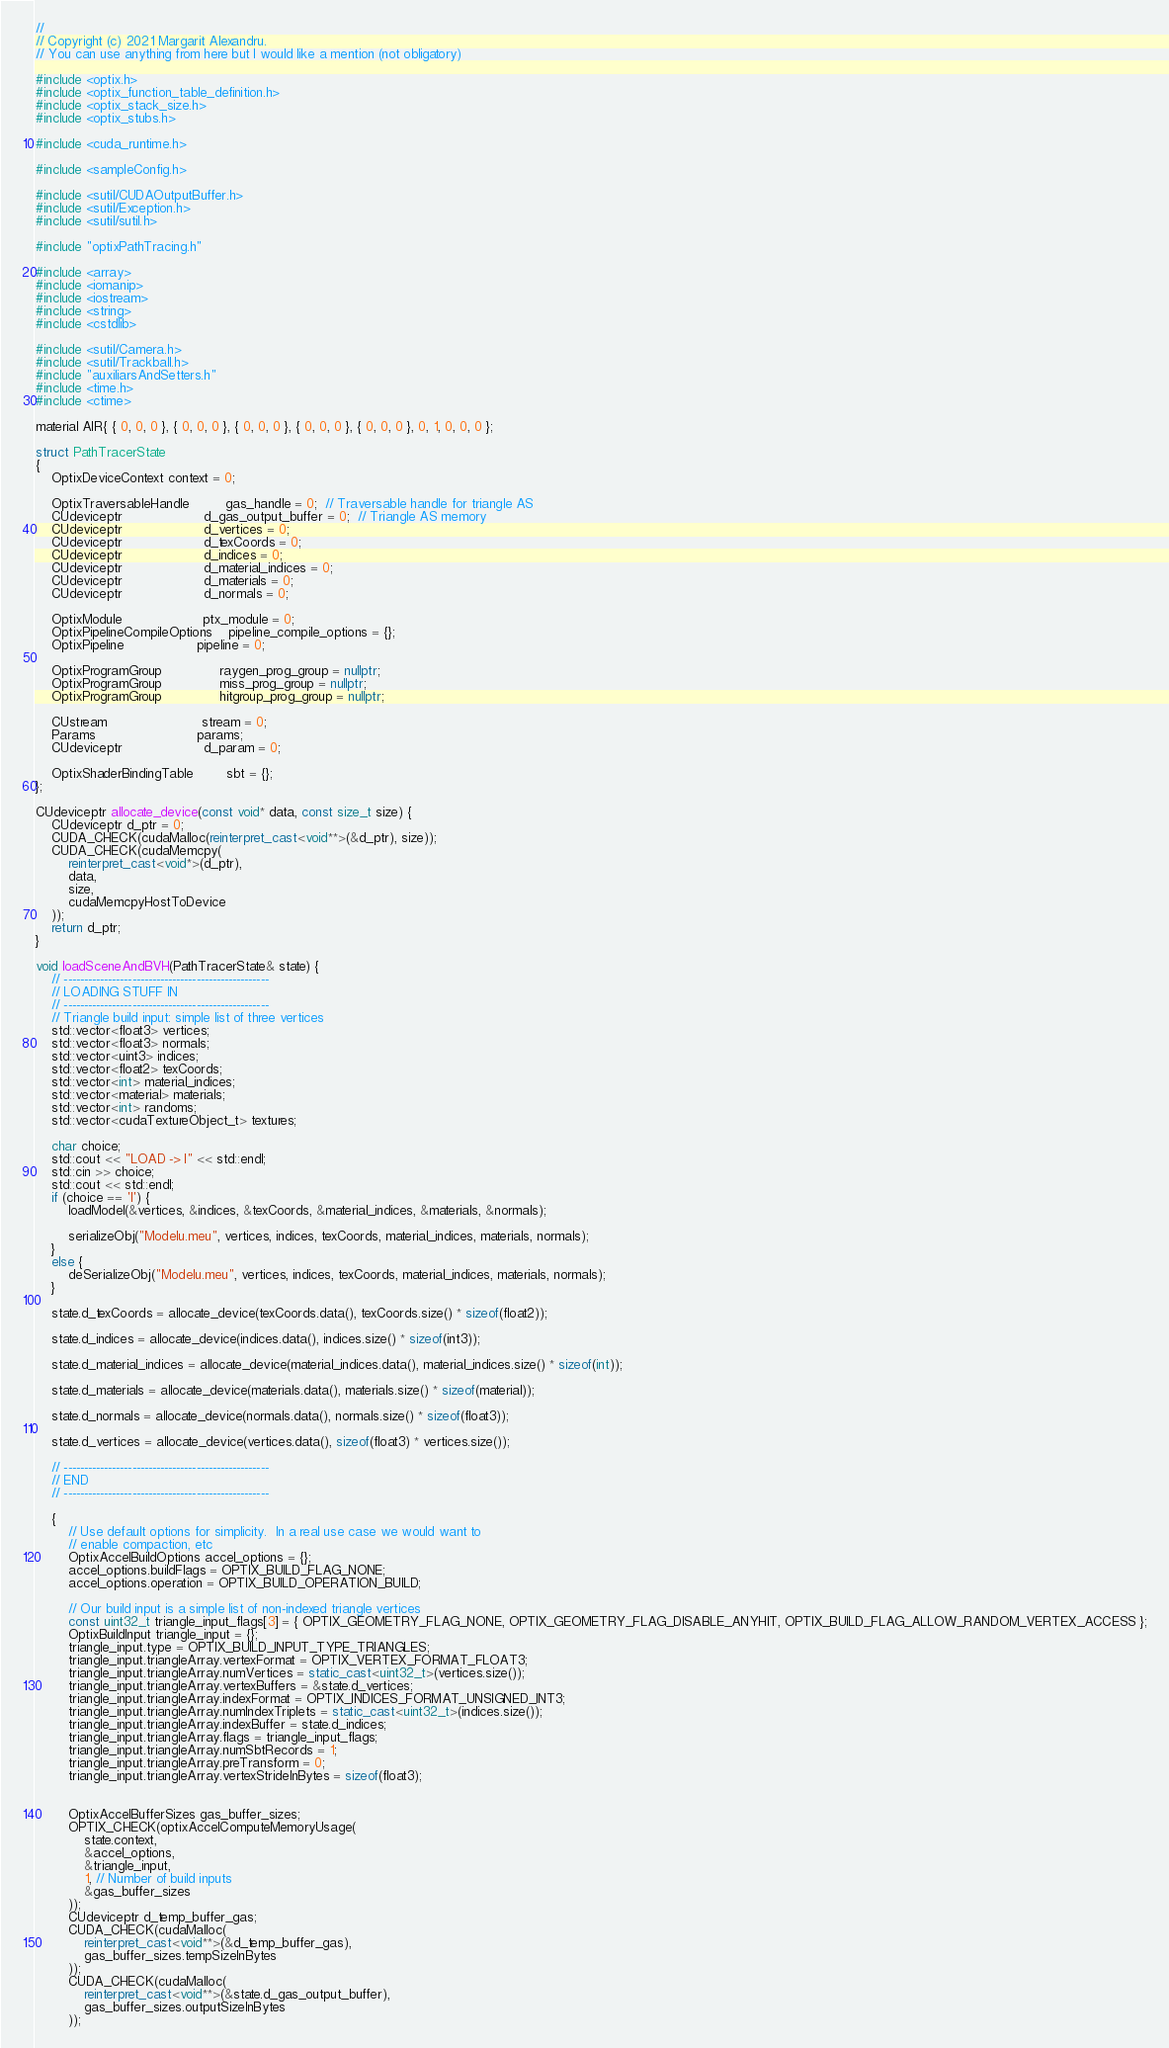<code> <loc_0><loc_0><loc_500><loc_500><_C++_>//
// Copyright (c) 2021 Margarit Alexandru.
// You can use anything from here but I would like a mention (not obligatory)

#include <optix.h>
#include <optix_function_table_definition.h>
#include <optix_stack_size.h>
#include <optix_stubs.h>

#include <cuda_runtime.h>

#include <sampleConfig.h>

#include <sutil/CUDAOutputBuffer.h>
#include <sutil/Exception.h>
#include <sutil/sutil.h>

#include "optixPathTracing.h"

#include <array>
#include <iomanip>
#include <iostream>
#include <string>
#include <cstdlib>

#include <sutil/Camera.h>
#include <sutil/Trackball.h>
#include "auxiliarsAndSetters.h"
#include <time.h>
#include <ctime>

material AIR{ { 0, 0, 0 }, { 0, 0, 0 }, { 0, 0, 0 }, { 0, 0, 0 }, { 0, 0, 0 }, 0, 1, 0, 0, 0 };

struct PathTracerState
{
    OptixDeviceContext context = 0;

    OptixTraversableHandle         gas_handle = 0;  // Traversable handle for triangle AS
    CUdeviceptr                    d_gas_output_buffer = 0;  // Triangle AS memory
    CUdeviceptr                    d_vertices = 0;
    CUdeviceptr                    d_texCoords = 0;
    CUdeviceptr                    d_indices = 0;
    CUdeviceptr                    d_material_indices = 0;
    CUdeviceptr                    d_materials = 0;
    CUdeviceptr                    d_normals = 0;

    OptixModule                    ptx_module = 0;
    OptixPipelineCompileOptions    pipeline_compile_options = {};
    OptixPipeline                  pipeline = 0;

    OptixProgramGroup              raygen_prog_group = nullptr;
    OptixProgramGroup              miss_prog_group = nullptr;
    OptixProgramGroup              hitgroup_prog_group = nullptr;

    CUstream                       stream = 0;
    Params                         params;
    CUdeviceptr                    d_param = 0;

    OptixShaderBindingTable        sbt = {};
};

CUdeviceptr allocate_device(const void* data, const size_t size) {
    CUdeviceptr d_ptr = 0;
    CUDA_CHECK(cudaMalloc(reinterpret_cast<void**>(&d_ptr), size));
    CUDA_CHECK(cudaMemcpy(
        reinterpret_cast<void*>(d_ptr),
        data,
        size,
        cudaMemcpyHostToDevice
    ));
    return d_ptr;
}

void loadSceneAndBVH(PathTracerState& state) {
    // ---------------------------------------------------
    // LOADING STUFF IN
    // ---------------------------------------------------
    // Triangle build input: simple list of three vertices
    std::vector<float3> vertices;
    std::vector<float3> normals;
    std::vector<uint3> indices;
    std::vector<float2> texCoords;
    std::vector<int> material_indices;
    std::vector<material> materials;
    std::vector<int> randoms;
    std::vector<cudaTextureObject_t> textures;

    char choice;
    std::cout << "LOAD -> l" << std::endl;
    std::cin >> choice;
    std::cout << std::endl;
    if (choice == 'l') {
        loadModel(&vertices, &indices, &texCoords, &material_indices, &materials, &normals);

        serializeObj("Modelu.meu", vertices, indices, texCoords, material_indices, materials, normals);
    }
    else {
        deSerializeObj("Modelu.meu", vertices, indices, texCoords, material_indices, materials, normals);
    }

    state.d_texCoords = allocate_device(texCoords.data(), texCoords.size() * sizeof(float2));

    state.d_indices = allocate_device(indices.data(), indices.size() * sizeof(int3));

    state.d_material_indices = allocate_device(material_indices.data(), material_indices.size() * sizeof(int));

    state.d_materials = allocate_device(materials.data(), materials.size() * sizeof(material));

    state.d_normals = allocate_device(normals.data(), normals.size() * sizeof(float3));

    state.d_vertices = allocate_device(vertices.data(), sizeof(float3) * vertices.size());

    // ---------------------------------------------------
    // END
    // ---------------------------------------------------

    {
        // Use default options for simplicity.  In a real use case we would want to
        // enable compaction, etc
        OptixAccelBuildOptions accel_options = {};
        accel_options.buildFlags = OPTIX_BUILD_FLAG_NONE;
        accel_options.operation = OPTIX_BUILD_OPERATION_BUILD;

        // Our build input is a simple list of non-indexed triangle vertices
        const uint32_t triangle_input_flags[3] = { OPTIX_GEOMETRY_FLAG_NONE, OPTIX_GEOMETRY_FLAG_DISABLE_ANYHIT, OPTIX_BUILD_FLAG_ALLOW_RANDOM_VERTEX_ACCESS };
        OptixBuildInput triangle_input = {};
        triangle_input.type = OPTIX_BUILD_INPUT_TYPE_TRIANGLES;
        triangle_input.triangleArray.vertexFormat = OPTIX_VERTEX_FORMAT_FLOAT3;
        triangle_input.triangleArray.numVertices = static_cast<uint32_t>(vertices.size());
        triangle_input.triangleArray.vertexBuffers = &state.d_vertices;
        triangle_input.triangleArray.indexFormat = OPTIX_INDICES_FORMAT_UNSIGNED_INT3;
        triangle_input.triangleArray.numIndexTriplets = static_cast<uint32_t>(indices.size());
        triangle_input.triangleArray.indexBuffer = state.d_indices;
        triangle_input.triangleArray.flags = triangle_input_flags;
        triangle_input.triangleArray.numSbtRecords = 1;
        triangle_input.triangleArray.preTransform = 0;
        triangle_input.triangleArray.vertexStrideInBytes = sizeof(float3);


        OptixAccelBufferSizes gas_buffer_sizes;
        OPTIX_CHECK(optixAccelComputeMemoryUsage(
            state.context,
            &accel_options,
            &triangle_input,
            1, // Number of build inputs
            &gas_buffer_sizes
        ));
        CUdeviceptr d_temp_buffer_gas;
        CUDA_CHECK(cudaMalloc(
            reinterpret_cast<void**>(&d_temp_buffer_gas),
            gas_buffer_sizes.tempSizeInBytes
        ));
        CUDA_CHECK(cudaMalloc(
            reinterpret_cast<void**>(&state.d_gas_output_buffer),
            gas_buffer_sizes.outputSizeInBytes
        ));
</code> 